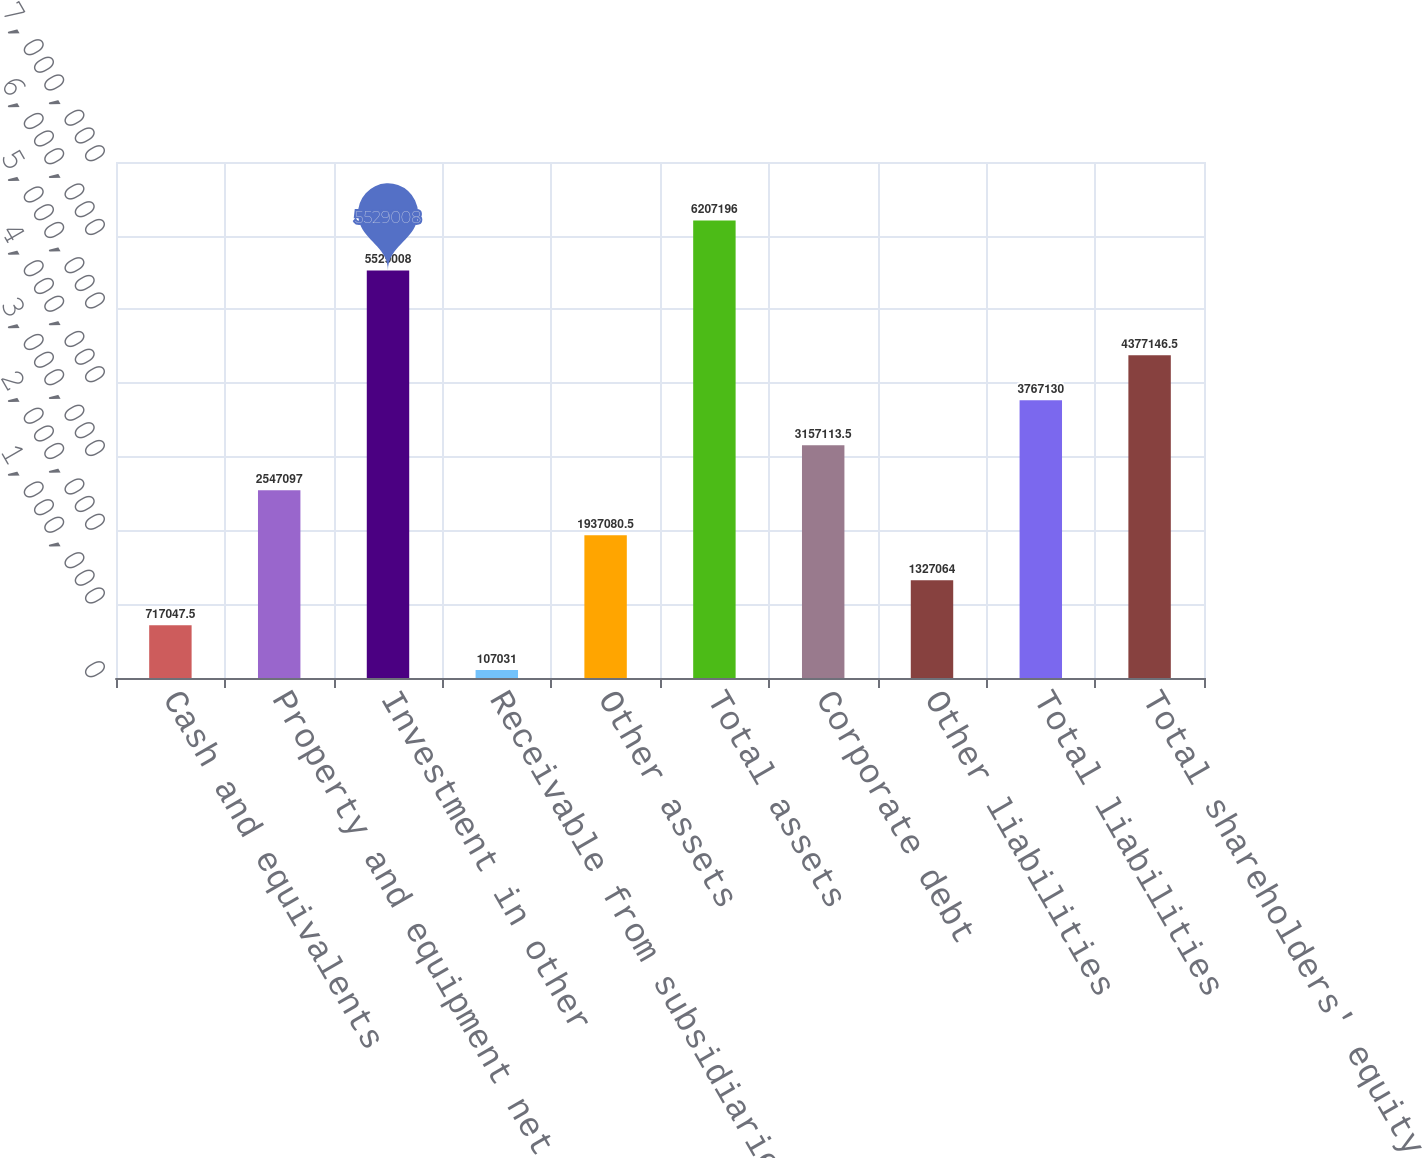Convert chart. <chart><loc_0><loc_0><loc_500><loc_500><bar_chart><fcel>Cash and equivalents<fcel>Property and equipment net<fcel>Investment in other<fcel>Receivable from subsidiaries<fcel>Other assets<fcel>Total assets<fcel>Corporate debt<fcel>Other liabilities<fcel>Total liabilities<fcel>Total shareholders' equity<nl><fcel>717048<fcel>2.5471e+06<fcel>5.52901e+06<fcel>107031<fcel>1.93708e+06<fcel>6.2072e+06<fcel>3.15711e+06<fcel>1.32706e+06<fcel>3.76713e+06<fcel>4.37715e+06<nl></chart> 